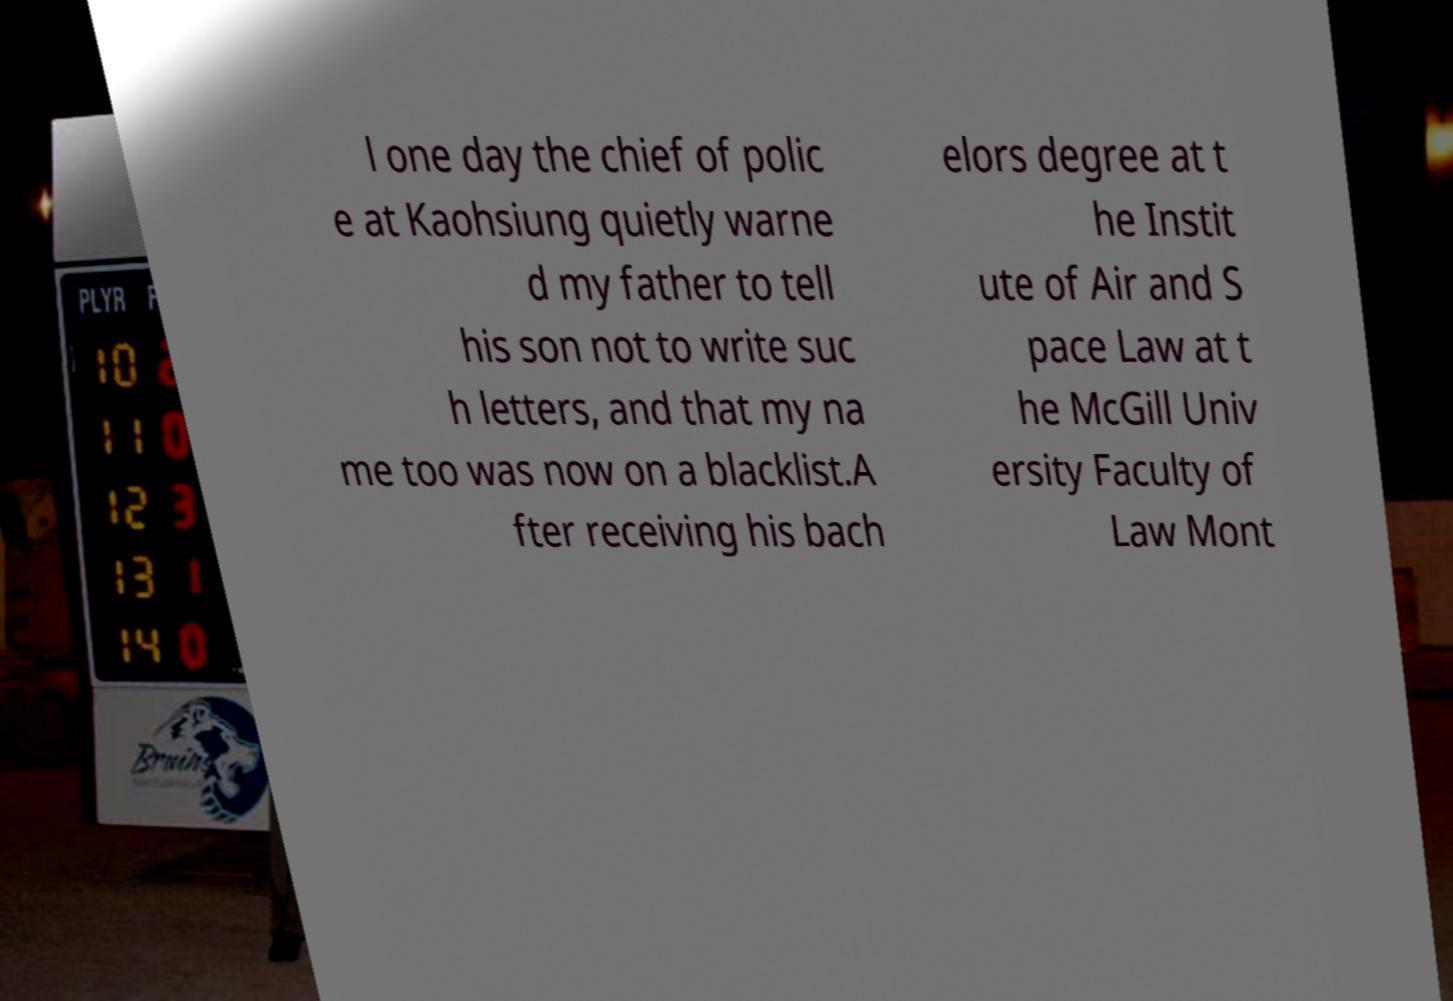Please read and relay the text visible in this image. What does it say? l one day the chief of polic e at Kaohsiung quietly warne d my father to tell his son not to write suc h letters, and that my na me too was now on a blacklist.A fter receiving his bach elors degree at t he Instit ute of Air and S pace Law at t he McGill Univ ersity Faculty of Law Mont 